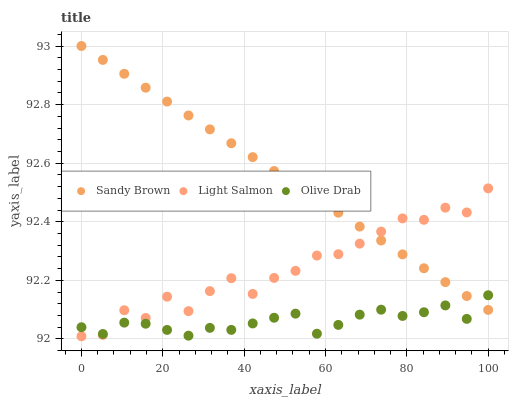Does Olive Drab have the minimum area under the curve?
Answer yes or no. Yes. Does Sandy Brown have the maximum area under the curve?
Answer yes or no. Yes. Does Sandy Brown have the minimum area under the curve?
Answer yes or no. No. Does Olive Drab have the maximum area under the curve?
Answer yes or no. No. Is Sandy Brown the smoothest?
Answer yes or no. Yes. Is Light Salmon the roughest?
Answer yes or no. Yes. Is Olive Drab the smoothest?
Answer yes or no. No. Is Olive Drab the roughest?
Answer yes or no. No. Does Light Salmon have the lowest value?
Answer yes or no. Yes. Does Olive Drab have the lowest value?
Answer yes or no. No. Does Sandy Brown have the highest value?
Answer yes or no. Yes. Does Olive Drab have the highest value?
Answer yes or no. No. Does Light Salmon intersect Sandy Brown?
Answer yes or no. Yes. Is Light Salmon less than Sandy Brown?
Answer yes or no. No. Is Light Salmon greater than Sandy Brown?
Answer yes or no. No. 